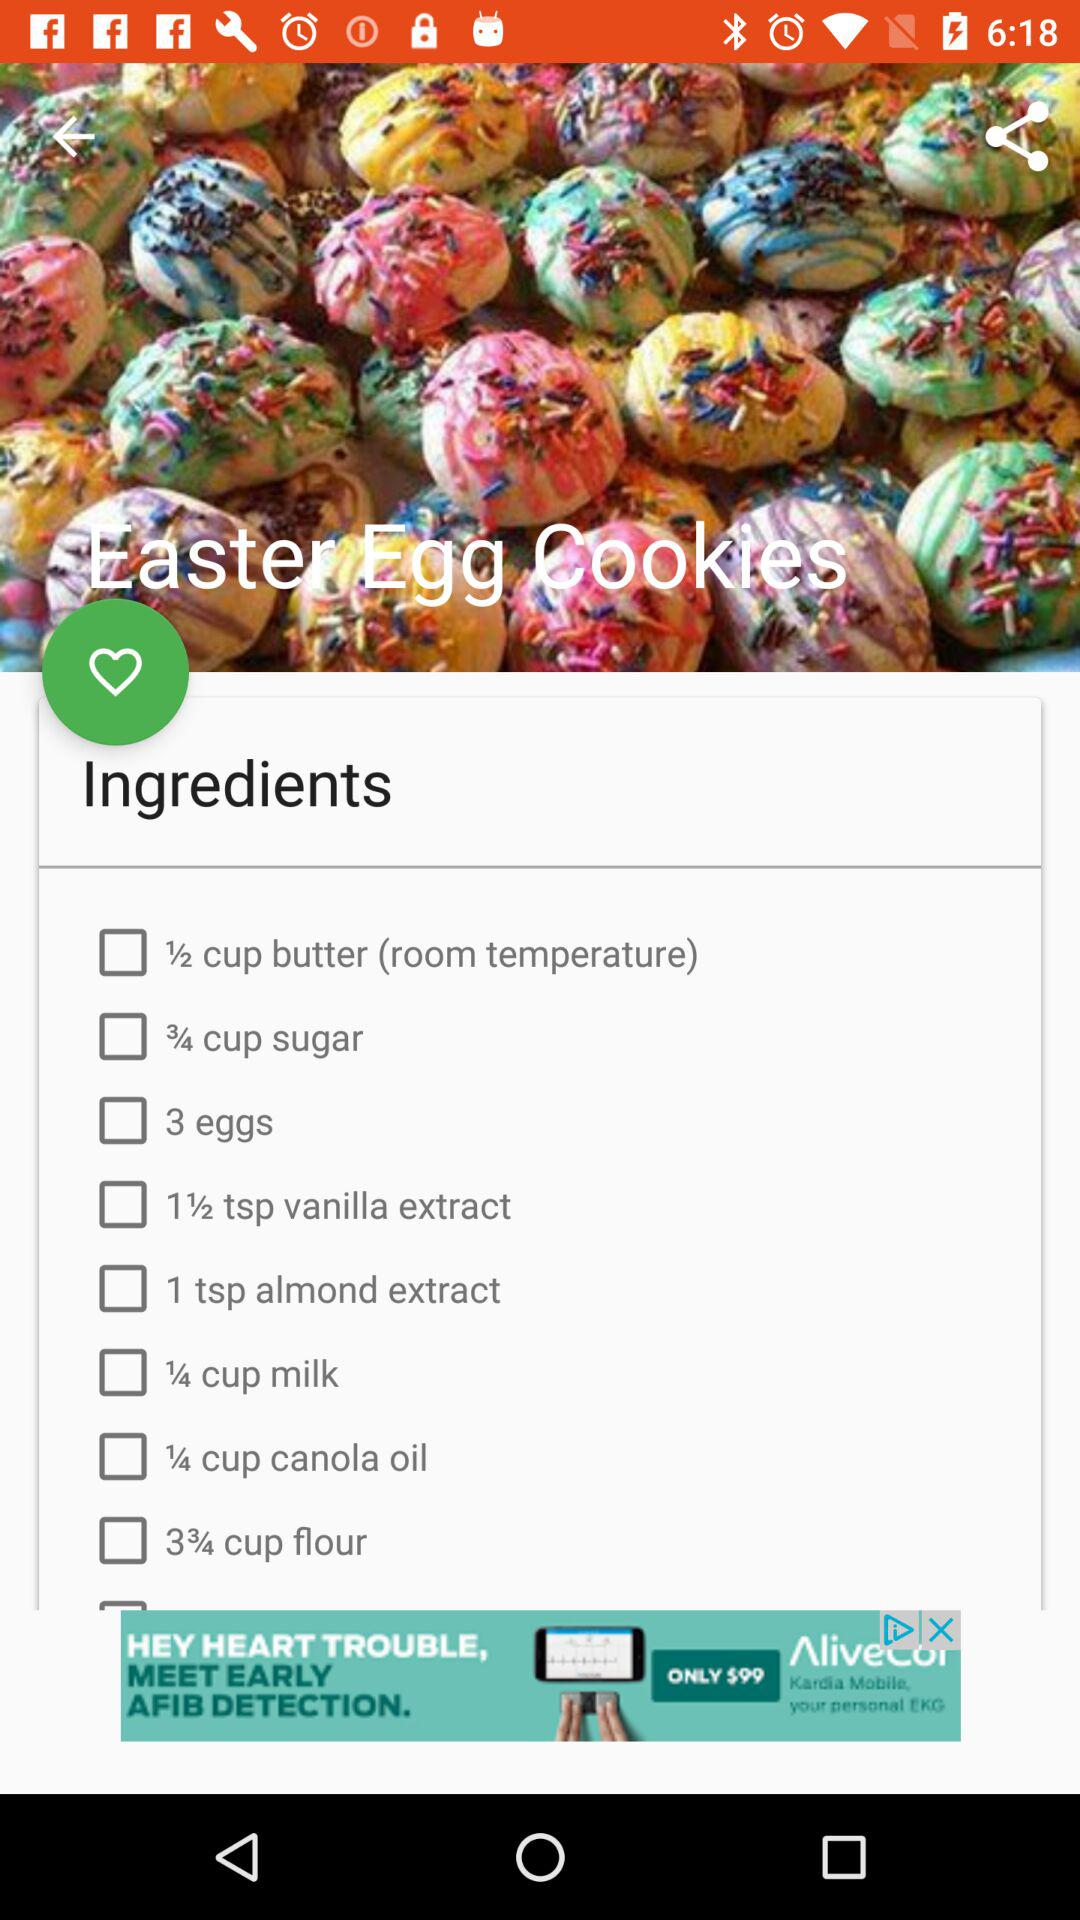What is the quantity of milk in the dish? The quantity of milk is 1/4 cup. 